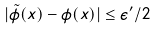<formula> <loc_0><loc_0><loc_500><loc_500>| \tilde { \phi } ( x ) - \phi ( x ) | \leq \epsilon ^ { \prime } / 2</formula> 